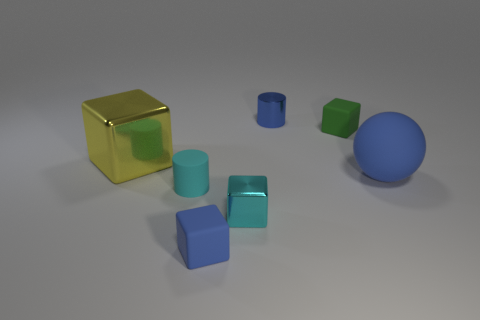There is a matte thing that is the same color as the large ball; what is its size?
Provide a short and direct response. Small. There is a small object that is the same color as the tiny rubber cylinder; what shape is it?
Provide a short and direct response. Cube. How many gray shiny balls are there?
Provide a succinct answer. 0. What number of cubes are either green objects or cyan rubber objects?
Make the answer very short. 1. There is a thing that is the same size as the blue sphere; what is its color?
Offer a terse response. Yellow. What number of rubber blocks are both left of the small green rubber thing and on the right side of the tiny cyan cube?
Make the answer very short. 0. What is the blue cylinder made of?
Keep it short and to the point. Metal. How many things are small green rubber blocks or tiny red objects?
Your response must be concise. 1. Does the thing to the left of the cyan matte object have the same size as the blue matte thing that is on the left side of the cyan cube?
Keep it short and to the point. No. What number of other objects are the same size as the cyan block?
Ensure brevity in your answer.  4. 